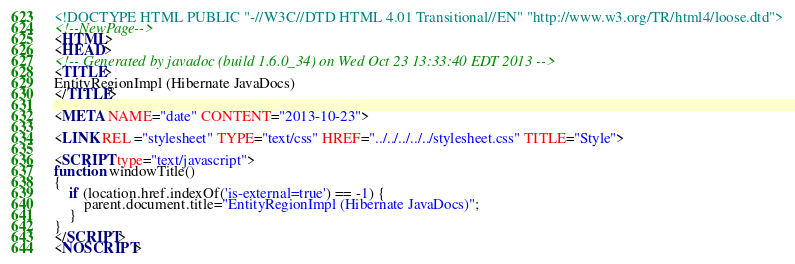<code> <loc_0><loc_0><loc_500><loc_500><_HTML_><!DOCTYPE HTML PUBLIC "-//W3C//DTD HTML 4.01 Transitional//EN" "http://www.w3.org/TR/html4/loose.dtd">
<!--NewPage-->
<HTML>
<HEAD>
<!-- Generated by javadoc (build 1.6.0_34) on Wed Oct 23 13:33:40 EDT 2013 -->
<TITLE>
EntityRegionImpl (Hibernate JavaDocs)
</TITLE>

<META NAME="date" CONTENT="2013-10-23">

<LINK REL ="stylesheet" TYPE="text/css" HREF="../../../../../stylesheet.css" TITLE="Style">

<SCRIPT type="text/javascript">
function windowTitle()
{
    if (location.href.indexOf('is-external=true') == -1) {
        parent.document.title="EntityRegionImpl (Hibernate JavaDocs)";
    }
}
</SCRIPT>
<NOSCRIPT></code> 